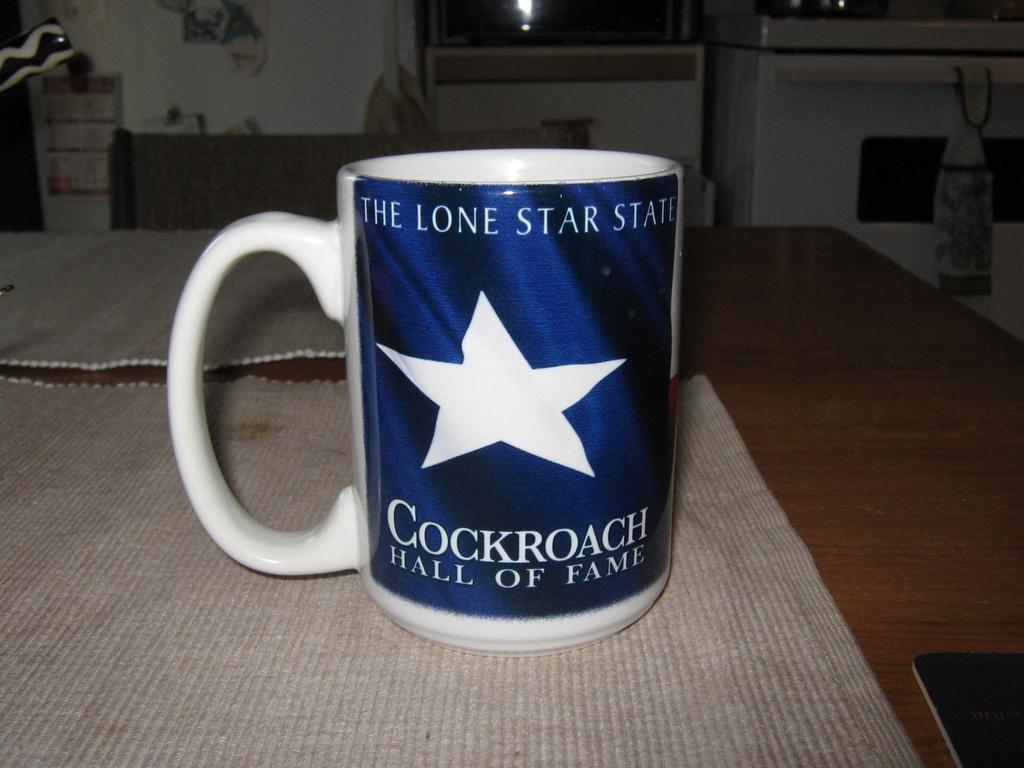<image>
Write a terse but informative summary of the picture. A coffee cup is labeled with Cockroach Hall of Fame. 